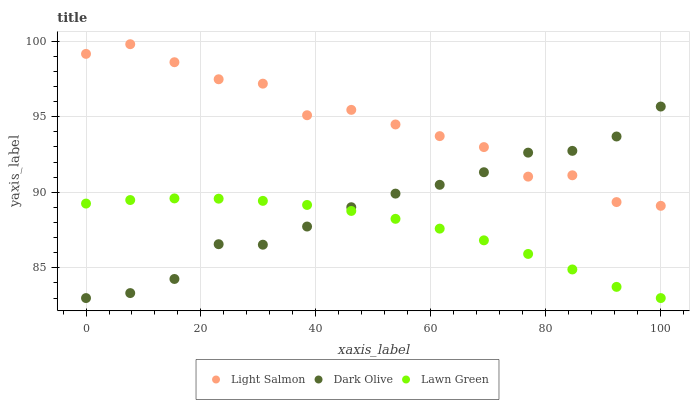Does Lawn Green have the minimum area under the curve?
Answer yes or no. Yes. Does Light Salmon have the maximum area under the curve?
Answer yes or no. Yes. Does Dark Olive have the minimum area under the curve?
Answer yes or no. No. Does Dark Olive have the maximum area under the curve?
Answer yes or no. No. Is Lawn Green the smoothest?
Answer yes or no. Yes. Is Light Salmon the roughest?
Answer yes or no. Yes. Is Dark Olive the smoothest?
Answer yes or no. No. Is Dark Olive the roughest?
Answer yes or no. No. Does Lawn Green have the lowest value?
Answer yes or no. Yes. Does Light Salmon have the lowest value?
Answer yes or no. No. Does Light Salmon have the highest value?
Answer yes or no. Yes. Does Dark Olive have the highest value?
Answer yes or no. No. Is Lawn Green less than Light Salmon?
Answer yes or no. Yes. Is Light Salmon greater than Lawn Green?
Answer yes or no. Yes. Does Dark Olive intersect Light Salmon?
Answer yes or no. Yes. Is Dark Olive less than Light Salmon?
Answer yes or no. No. Is Dark Olive greater than Light Salmon?
Answer yes or no. No. Does Lawn Green intersect Light Salmon?
Answer yes or no. No. 